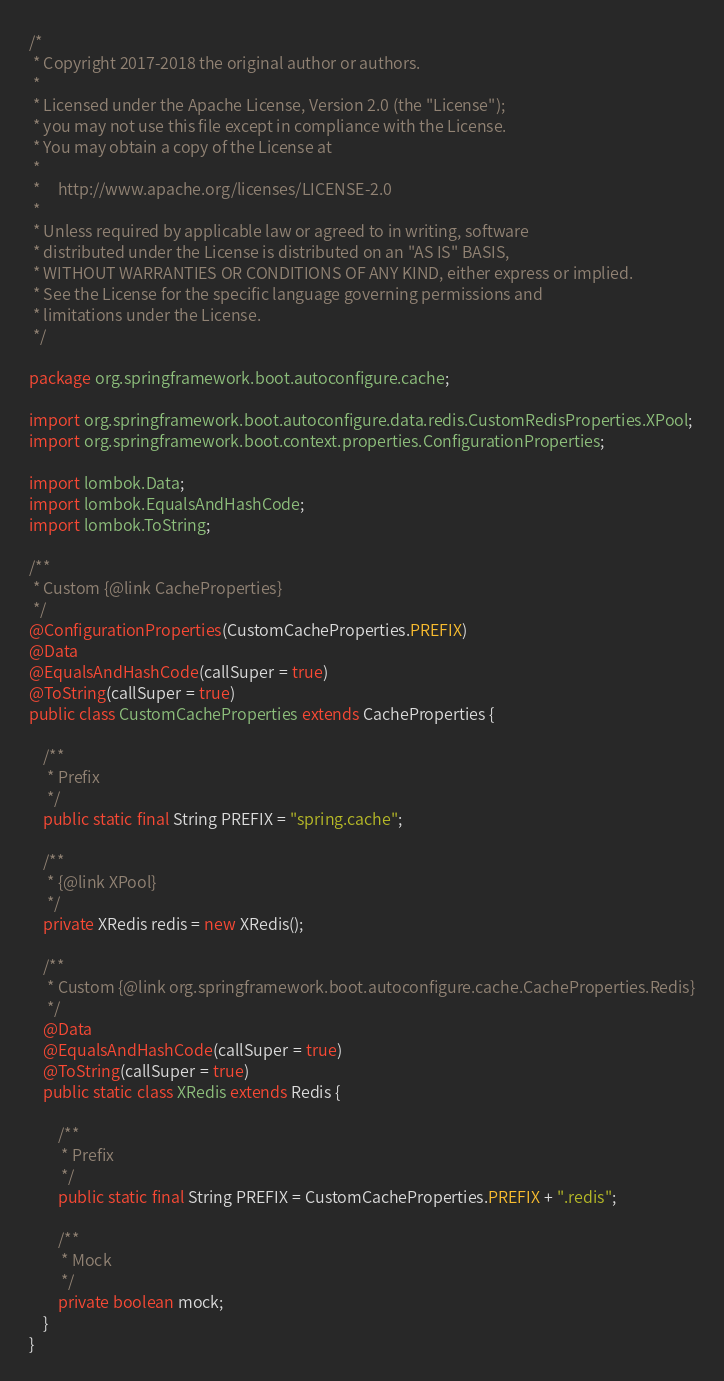Convert code to text. <code><loc_0><loc_0><loc_500><loc_500><_Java_>/*
 * Copyright 2017-2018 the original author or authors.
 *
 * Licensed under the Apache License, Version 2.0 (the "License");
 * you may not use this file except in compliance with the License.
 * You may obtain a copy of the License at
 *
 *     http://www.apache.org/licenses/LICENSE-2.0
 *
 * Unless required by applicable law or agreed to in writing, software
 * distributed under the License is distributed on an "AS IS" BASIS,
 * WITHOUT WARRANTIES OR CONDITIONS OF ANY KIND, either express or implied.
 * See the License for the specific language governing permissions and
 * limitations under the License.
 */

package org.springframework.boot.autoconfigure.cache;

import org.springframework.boot.autoconfigure.data.redis.CustomRedisProperties.XPool;
import org.springframework.boot.context.properties.ConfigurationProperties;

import lombok.Data;
import lombok.EqualsAndHashCode;
import lombok.ToString;

/**
 * Custom {@link CacheProperties}
 */
@ConfigurationProperties(CustomCacheProperties.PREFIX)
@Data
@EqualsAndHashCode(callSuper = true)
@ToString(callSuper = true)
public class CustomCacheProperties extends CacheProperties {
	
	/**
	 * Prefix
	 */
	public static final String PREFIX = "spring.cache";
	
	/**
	 * {@link XPool}
	 */
	private XRedis redis = new XRedis();
	
	/**
	 * Custom {@link org.springframework.boot.autoconfigure.cache.CacheProperties.Redis}
	 */
	@Data
	@EqualsAndHashCode(callSuper = true)
	@ToString(callSuper = true)
	public static class XRedis extends Redis {
		
		/**
		 * Prefix
		 */
		public static final String PREFIX = CustomCacheProperties.PREFIX + ".redis";
		
		/**
		 * Mock
		 */
		private boolean mock;
	}
}
</code> 